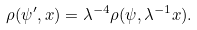<formula> <loc_0><loc_0><loc_500><loc_500>\rho ( \psi ^ { \prime } , x ) = \lambda ^ { - 4 } \rho ( \psi , \lambda ^ { - 1 } x ) .</formula> 